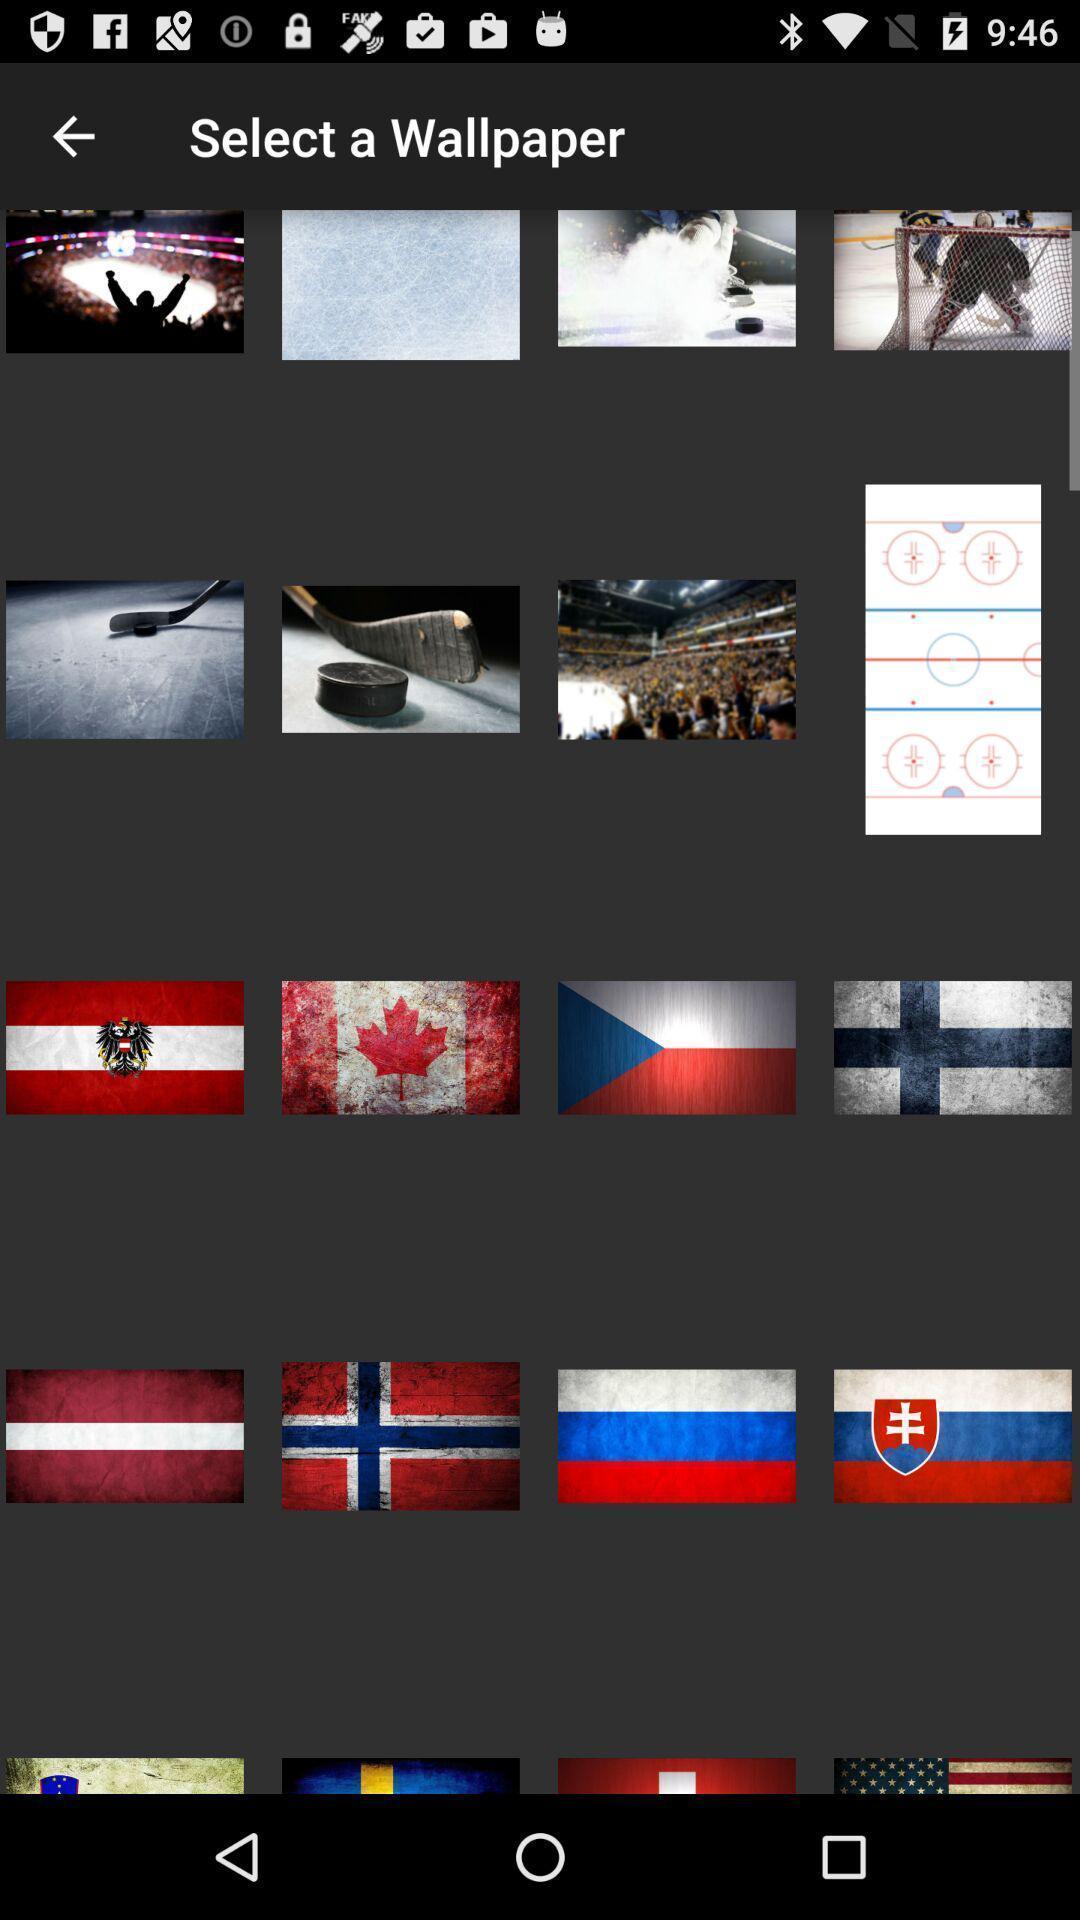Explain the elements present in this screenshot. Page showing lot of wallpaper designs. 